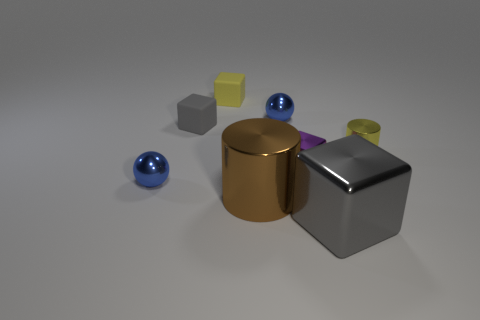Subtract all large cubes. How many cubes are left? 3 Subtract all red balls. How many gray blocks are left? 2 Subtract 2 cubes. How many cubes are left? 2 Subtract all purple blocks. How many blocks are left? 3 Add 2 tiny rubber cubes. How many objects exist? 10 Subtract all blue blocks. Subtract all blue balls. How many blocks are left? 4 Subtract all spheres. How many objects are left? 6 Add 5 small shiny things. How many small shiny things are left? 9 Add 8 big gray blocks. How many big gray blocks exist? 9 Subtract 0 cyan spheres. How many objects are left? 8 